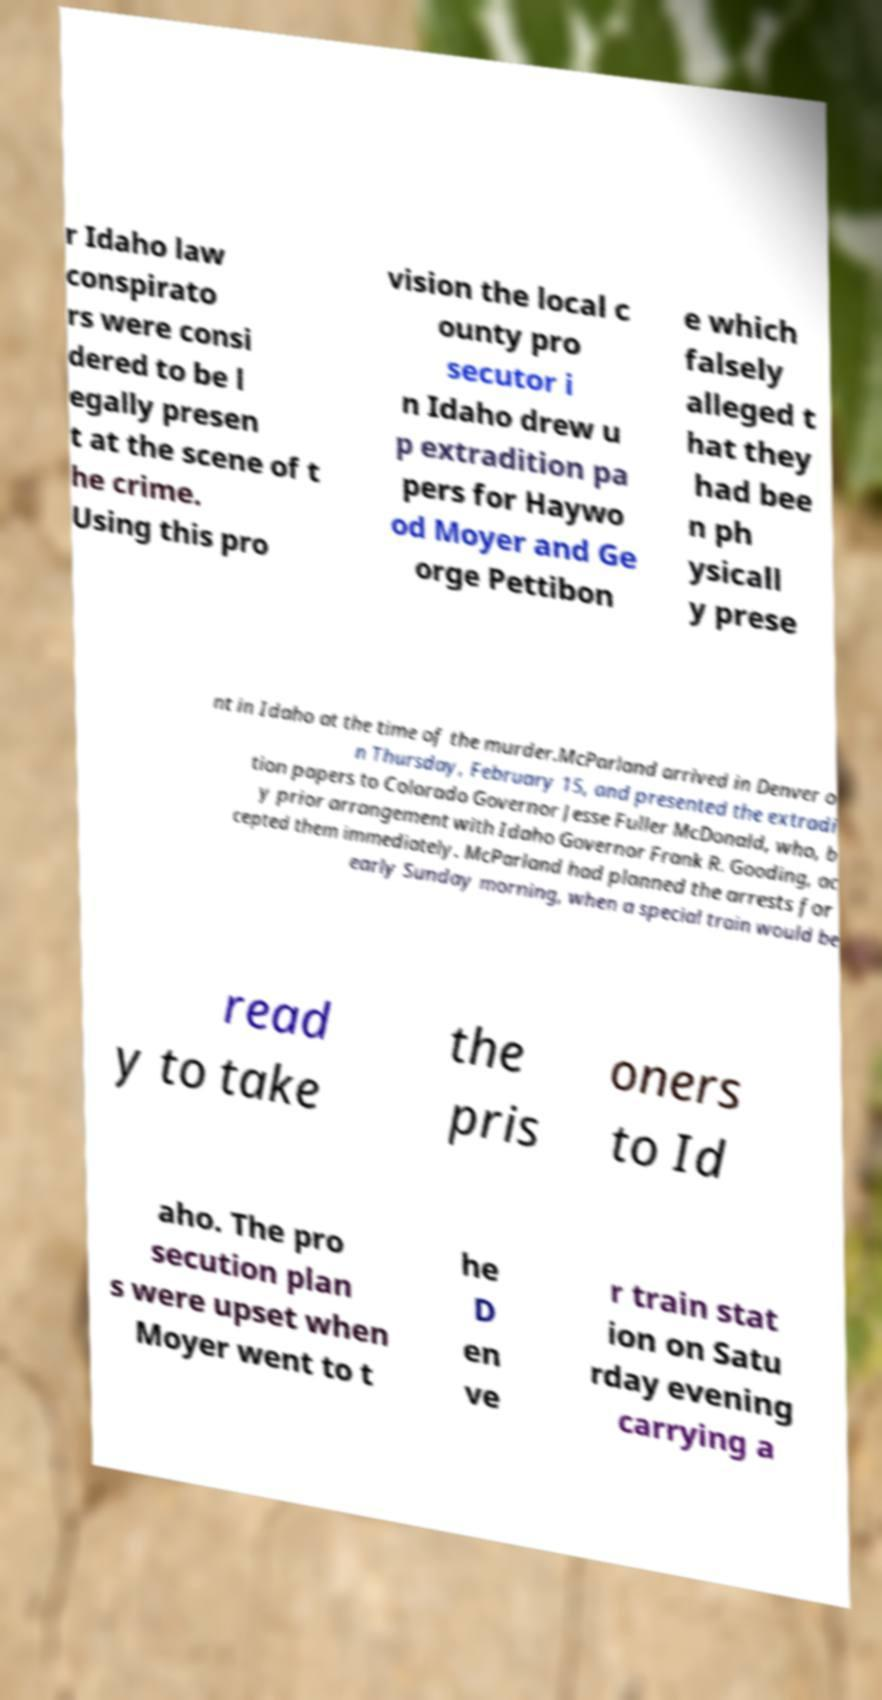Please identify and transcribe the text found in this image. r Idaho law conspirato rs were consi dered to be l egally presen t at the scene of t he crime. Using this pro vision the local c ounty pro secutor i n Idaho drew u p extradition pa pers for Haywo od Moyer and Ge orge Pettibon e which falsely alleged t hat they had bee n ph ysicall y prese nt in Idaho at the time of the murder.McParland arrived in Denver o n Thursday, February 15, and presented the extradi tion papers to Colorado Governor Jesse Fuller McDonald, who, b y prior arrangement with Idaho Governor Frank R. Gooding, ac cepted them immediately. McParland had planned the arrests for early Sunday morning, when a special train would be read y to take the pris oners to Id aho. The pro secution plan s were upset when Moyer went to t he D en ve r train stat ion on Satu rday evening carrying a 